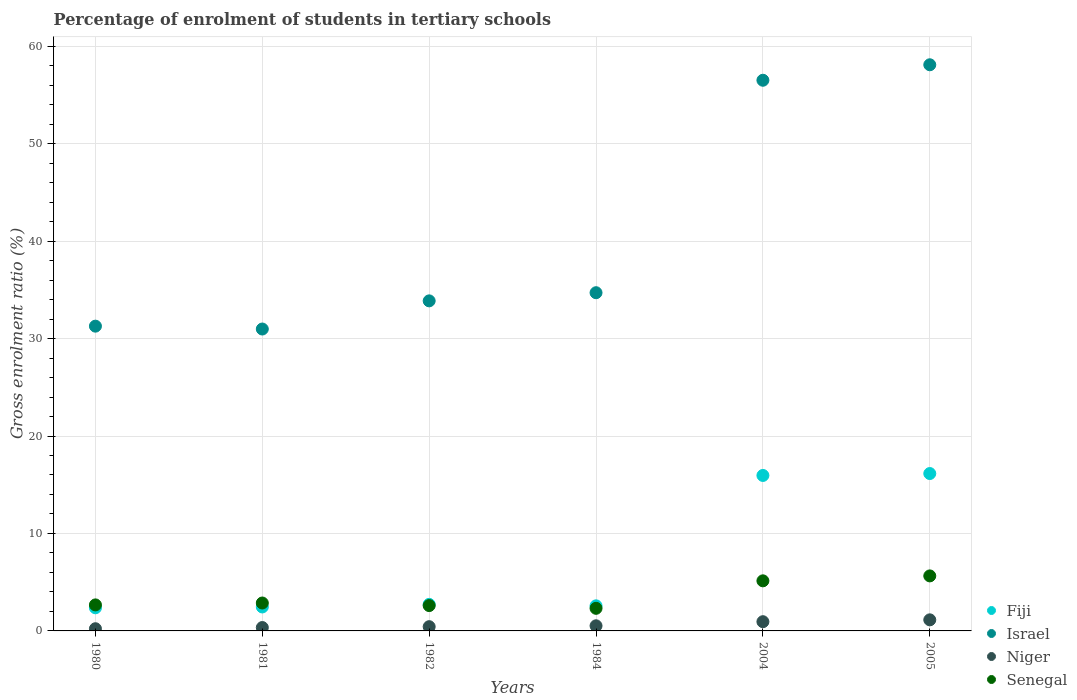What is the percentage of students enrolled in tertiary schools in Israel in 1982?
Provide a short and direct response. 33.87. Across all years, what is the maximum percentage of students enrolled in tertiary schools in Niger?
Your answer should be very brief. 1.14. Across all years, what is the minimum percentage of students enrolled in tertiary schools in Niger?
Give a very brief answer. 0.23. In which year was the percentage of students enrolled in tertiary schools in Fiji minimum?
Provide a short and direct response. 1980. What is the total percentage of students enrolled in tertiary schools in Niger in the graph?
Make the answer very short. 3.62. What is the difference between the percentage of students enrolled in tertiary schools in Niger in 1980 and that in 1984?
Give a very brief answer. -0.3. What is the difference between the percentage of students enrolled in tertiary schools in Senegal in 1984 and the percentage of students enrolled in tertiary schools in Israel in 1981?
Make the answer very short. -28.66. What is the average percentage of students enrolled in tertiary schools in Niger per year?
Keep it short and to the point. 0.6. In the year 1984, what is the difference between the percentage of students enrolled in tertiary schools in Niger and percentage of students enrolled in tertiary schools in Senegal?
Your answer should be very brief. -1.79. In how many years, is the percentage of students enrolled in tertiary schools in Niger greater than 20 %?
Your answer should be very brief. 0. What is the ratio of the percentage of students enrolled in tertiary schools in Niger in 1981 to that in 2005?
Keep it short and to the point. 0.31. Is the percentage of students enrolled in tertiary schools in Senegal in 1982 less than that in 2005?
Ensure brevity in your answer.  Yes. Is the difference between the percentage of students enrolled in tertiary schools in Niger in 1981 and 1984 greater than the difference between the percentage of students enrolled in tertiary schools in Senegal in 1981 and 1984?
Keep it short and to the point. No. What is the difference between the highest and the second highest percentage of students enrolled in tertiary schools in Niger?
Ensure brevity in your answer.  0.19. What is the difference between the highest and the lowest percentage of students enrolled in tertiary schools in Israel?
Your answer should be compact. 27.11. Is the sum of the percentage of students enrolled in tertiary schools in Senegal in 1984 and 2004 greater than the maximum percentage of students enrolled in tertiary schools in Niger across all years?
Give a very brief answer. Yes. Is it the case that in every year, the sum of the percentage of students enrolled in tertiary schools in Senegal and percentage of students enrolled in tertiary schools in Niger  is greater than the sum of percentage of students enrolled in tertiary schools in Israel and percentage of students enrolled in tertiary schools in Fiji?
Provide a short and direct response. No. Is it the case that in every year, the sum of the percentage of students enrolled in tertiary schools in Senegal and percentage of students enrolled in tertiary schools in Fiji  is greater than the percentage of students enrolled in tertiary schools in Niger?
Provide a succinct answer. Yes. Does the percentage of students enrolled in tertiary schools in Fiji monotonically increase over the years?
Provide a short and direct response. No. How many dotlines are there?
Provide a succinct answer. 4. What is the difference between two consecutive major ticks on the Y-axis?
Give a very brief answer. 10. Does the graph contain any zero values?
Make the answer very short. No. How are the legend labels stacked?
Your answer should be compact. Vertical. What is the title of the graph?
Ensure brevity in your answer.  Percentage of enrolment of students in tertiary schools. What is the label or title of the X-axis?
Your response must be concise. Years. What is the Gross enrolment ratio (%) of Fiji in 1980?
Keep it short and to the point. 2.37. What is the Gross enrolment ratio (%) of Israel in 1980?
Give a very brief answer. 31.27. What is the Gross enrolment ratio (%) in Niger in 1980?
Offer a very short reply. 0.23. What is the Gross enrolment ratio (%) in Senegal in 1980?
Provide a short and direct response. 2.67. What is the Gross enrolment ratio (%) in Fiji in 1981?
Offer a very short reply. 2.46. What is the Gross enrolment ratio (%) of Israel in 1981?
Your answer should be very brief. 30.98. What is the Gross enrolment ratio (%) in Niger in 1981?
Offer a terse response. 0.35. What is the Gross enrolment ratio (%) of Senegal in 1981?
Give a very brief answer. 2.86. What is the Gross enrolment ratio (%) of Fiji in 1982?
Provide a short and direct response. 2.72. What is the Gross enrolment ratio (%) of Israel in 1982?
Keep it short and to the point. 33.87. What is the Gross enrolment ratio (%) of Niger in 1982?
Offer a very short reply. 0.44. What is the Gross enrolment ratio (%) in Senegal in 1982?
Keep it short and to the point. 2.6. What is the Gross enrolment ratio (%) in Fiji in 1984?
Offer a terse response. 2.57. What is the Gross enrolment ratio (%) in Israel in 1984?
Your answer should be very brief. 34.7. What is the Gross enrolment ratio (%) of Niger in 1984?
Offer a terse response. 0.53. What is the Gross enrolment ratio (%) in Senegal in 1984?
Ensure brevity in your answer.  2.32. What is the Gross enrolment ratio (%) in Fiji in 2004?
Provide a succinct answer. 15.95. What is the Gross enrolment ratio (%) of Israel in 2004?
Keep it short and to the point. 56.5. What is the Gross enrolment ratio (%) in Niger in 2004?
Provide a short and direct response. 0.95. What is the Gross enrolment ratio (%) in Senegal in 2004?
Offer a very short reply. 5.14. What is the Gross enrolment ratio (%) of Fiji in 2005?
Your response must be concise. 16.15. What is the Gross enrolment ratio (%) in Israel in 2005?
Ensure brevity in your answer.  58.09. What is the Gross enrolment ratio (%) of Niger in 2005?
Offer a very short reply. 1.14. What is the Gross enrolment ratio (%) in Senegal in 2005?
Your answer should be very brief. 5.64. Across all years, what is the maximum Gross enrolment ratio (%) of Fiji?
Make the answer very short. 16.15. Across all years, what is the maximum Gross enrolment ratio (%) in Israel?
Provide a succinct answer. 58.09. Across all years, what is the maximum Gross enrolment ratio (%) of Niger?
Ensure brevity in your answer.  1.14. Across all years, what is the maximum Gross enrolment ratio (%) of Senegal?
Provide a succinct answer. 5.64. Across all years, what is the minimum Gross enrolment ratio (%) of Fiji?
Provide a succinct answer. 2.37. Across all years, what is the minimum Gross enrolment ratio (%) in Israel?
Your response must be concise. 30.98. Across all years, what is the minimum Gross enrolment ratio (%) of Niger?
Your answer should be compact. 0.23. Across all years, what is the minimum Gross enrolment ratio (%) of Senegal?
Your response must be concise. 2.32. What is the total Gross enrolment ratio (%) in Fiji in the graph?
Provide a short and direct response. 42.23. What is the total Gross enrolment ratio (%) in Israel in the graph?
Ensure brevity in your answer.  245.41. What is the total Gross enrolment ratio (%) in Niger in the graph?
Give a very brief answer. 3.62. What is the total Gross enrolment ratio (%) in Senegal in the graph?
Keep it short and to the point. 21.24. What is the difference between the Gross enrolment ratio (%) of Fiji in 1980 and that in 1981?
Offer a terse response. -0.09. What is the difference between the Gross enrolment ratio (%) in Israel in 1980 and that in 1981?
Your answer should be very brief. 0.29. What is the difference between the Gross enrolment ratio (%) of Niger in 1980 and that in 1981?
Keep it short and to the point. -0.12. What is the difference between the Gross enrolment ratio (%) in Senegal in 1980 and that in 1981?
Ensure brevity in your answer.  -0.19. What is the difference between the Gross enrolment ratio (%) of Fiji in 1980 and that in 1982?
Make the answer very short. -0.35. What is the difference between the Gross enrolment ratio (%) in Israel in 1980 and that in 1982?
Give a very brief answer. -2.6. What is the difference between the Gross enrolment ratio (%) of Niger in 1980 and that in 1982?
Your answer should be compact. -0.21. What is the difference between the Gross enrolment ratio (%) in Senegal in 1980 and that in 1982?
Provide a short and direct response. 0.07. What is the difference between the Gross enrolment ratio (%) of Fiji in 1980 and that in 1984?
Your answer should be very brief. -0.2. What is the difference between the Gross enrolment ratio (%) in Israel in 1980 and that in 1984?
Offer a terse response. -3.43. What is the difference between the Gross enrolment ratio (%) in Niger in 1980 and that in 1984?
Your response must be concise. -0.3. What is the difference between the Gross enrolment ratio (%) in Senegal in 1980 and that in 1984?
Offer a very short reply. 0.35. What is the difference between the Gross enrolment ratio (%) in Fiji in 1980 and that in 2004?
Ensure brevity in your answer.  -13.58. What is the difference between the Gross enrolment ratio (%) in Israel in 1980 and that in 2004?
Keep it short and to the point. -25.23. What is the difference between the Gross enrolment ratio (%) in Niger in 1980 and that in 2004?
Offer a terse response. -0.72. What is the difference between the Gross enrolment ratio (%) of Senegal in 1980 and that in 2004?
Provide a short and direct response. -2.47. What is the difference between the Gross enrolment ratio (%) of Fiji in 1980 and that in 2005?
Your answer should be compact. -13.78. What is the difference between the Gross enrolment ratio (%) in Israel in 1980 and that in 2005?
Your answer should be compact. -26.82. What is the difference between the Gross enrolment ratio (%) in Niger in 1980 and that in 2005?
Give a very brief answer. -0.91. What is the difference between the Gross enrolment ratio (%) in Senegal in 1980 and that in 2005?
Your response must be concise. -2.97. What is the difference between the Gross enrolment ratio (%) of Fiji in 1981 and that in 1982?
Your answer should be very brief. -0.27. What is the difference between the Gross enrolment ratio (%) of Israel in 1981 and that in 1982?
Your answer should be very brief. -2.89. What is the difference between the Gross enrolment ratio (%) in Niger in 1981 and that in 1982?
Provide a succinct answer. -0.09. What is the difference between the Gross enrolment ratio (%) in Senegal in 1981 and that in 1982?
Give a very brief answer. 0.27. What is the difference between the Gross enrolment ratio (%) in Fiji in 1981 and that in 1984?
Ensure brevity in your answer.  -0.12. What is the difference between the Gross enrolment ratio (%) of Israel in 1981 and that in 1984?
Your answer should be very brief. -3.73. What is the difference between the Gross enrolment ratio (%) in Niger in 1981 and that in 1984?
Your response must be concise. -0.18. What is the difference between the Gross enrolment ratio (%) of Senegal in 1981 and that in 1984?
Provide a short and direct response. 0.55. What is the difference between the Gross enrolment ratio (%) in Fiji in 1981 and that in 2004?
Provide a short and direct response. -13.49. What is the difference between the Gross enrolment ratio (%) in Israel in 1981 and that in 2004?
Offer a terse response. -25.53. What is the difference between the Gross enrolment ratio (%) of Niger in 1981 and that in 2004?
Make the answer very short. -0.6. What is the difference between the Gross enrolment ratio (%) in Senegal in 1981 and that in 2004?
Your answer should be very brief. -2.27. What is the difference between the Gross enrolment ratio (%) of Fiji in 1981 and that in 2005?
Provide a short and direct response. -13.69. What is the difference between the Gross enrolment ratio (%) in Israel in 1981 and that in 2005?
Offer a very short reply. -27.11. What is the difference between the Gross enrolment ratio (%) of Niger in 1981 and that in 2005?
Provide a short and direct response. -0.79. What is the difference between the Gross enrolment ratio (%) in Senegal in 1981 and that in 2005?
Your answer should be compact. -2.78. What is the difference between the Gross enrolment ratio (%) of Fiji in 1982 and that in 1984?
Your answer should be compact. 0.15. What is the difference between the Gross enrolment ratio (%) in Israel in 1982 and that in 1984?
Provide a short and direct response. -0.84. What is the difference between the Gross enrolment ratio (%) in Niger in 1982 and that in 1984?
Give a very brief answer. -0.09. What is the difference between the Gross enrolment ratio (%) of Senegal in 1982 and that in 1984?
Provide a short and direct response. 0.28. What is the difference between the Gross enrolment ratio (%) of Fiji in 1982 and that in 2004?
Provide a succinct answer. -13.23. What is the difference between the Gross enrolment ratio (%) of Israel in 1982 and that in 2004?
Provide a short and direct response. -22.64. What is the difference between the Gross enrolment ratio (%) in Niger in 1982 and that in 2004?
Offer a terse response. -0.51. What is the difference between the Gross enrolment ratio (%) in Senegal in 1982 and that in 2004?
Keep it short and to the point. -2.54. What is the difference between the Gross enrolment ratio (%) in Fiji in 1982 and that in 2005?
Offer a terse response. -13.42. What is the difference between the Gross enrolment ratio (%) of Israel in 1982 and that in 2005?
Offer a terse response. -24.22. What is the difference between the Gross enrolment ratio (%) of Niger in 1982 and that in 2005?
Provide a short and direct response. -0.7. What is the difference between the Gross enrolment ratio (%) of Senegal in 1982 and that in 2005?
Provide a short and direct response. -3.05. What is the difference between the Gross enrolment ratio (%) of Fiji in 1984 and that in 2004?
Provide a succinct answer. -13.38. What is the difference between the Gross enrolment ratio (%) in Israel in 1984 and that in 2004?
Offer a very short reply. -21.8. What is the difference between the Gross enrolment ratio (%) of Niger in 1984 and that in 2004?
Make the answer very short. -0.42. What is the difference between the Gross enrolment ratio (%) of Senegal in 1984 and that in 2004?
Your response must be concise. -2.82. What is the difference between the Gross enrolment ratio (%) of Fiji in 1984 and that in 2005?
Provide a short and direct response. -13.57. What is the difference between the Gross enrolment ratio (%) in Israel in 1984 and that in 2005?
Your answer should be compact. -23.39. What is the difference between the Gross enrolment ratio (%) in Niger in 1984 and that in 2005?
Make the answer very short. -0.61. What is the difference between the Gross enrolment ratio (%) in Senegal in 1984 and that in 2005?
Make the answer very short. -3.33. What is the difference between the Gross enrolment ratio (%) in Fiji in 2004 and that in 2005?
Offer a terse response. -0.2. What is the difference between the Gross enrolment ratio (%) of Israel in 2004 and that in 2005?
Provide a succinct answer. -1.59. What is the difference between the Gross enrolment ratio (%) of Niger in 2004 and that in 2005?
Offer a terse response. -0.19. What is the difference between the Gross enrolment ratio (%) of Senegal in 2004 and that in 2005?
Provide a short and direct response. -0.51. What is the difference between the Gross enrolment ratio (%) in Fiji in 1980 and the Gross enrolment ratio (%) in Israel in 1981?
Your answer should be compact. -28.6. What is the difference between the Gross enrolment ratio (%) in Fiji in 1980 and the Gross enrolment ratio (%) in Niger in 1981?
Provide a succinct answer. 2.03. What is the difference between the Gross enrolment ratio (%) of Fiji in 1980 and the Gross enrolment ratio (%) of Senegal in 1981?
Your answer should be very brief. -0.49. What is the difference between the Gross enrolment ratio (%) of Israel in 1980 and the Gross enrolment ratio (%) of Niger in 1981?
Provide a short and direct response. 30.92. What is the difference between the Gross enrolment ratio (%) in Israel in 1980 and the Gross enrolment ratio (%) in Senegal in 1981?
Keep it short and to the point. 28.41. What is the difference between the Gross enrolment ratio (%) in Niger in 1980 and the Gross enrolment ratio (%) in Senegal in 1981?
Provide a succinct answer. -2.64. What is the difference between the Gross enrolment ratio (%) of Fiji in 1980 and the Gross enrolment ratio (%) of Israel in 1982?
Make the answer very short. -31.49. What is the difference between the Gross enrolment ratio (%) of Fiji in 1980 and the Gross enrolment ratio (%) of Niger in 1982?
Your response must be concise. 1.94. What is the difference between the Gross enrolment ratio (%) in Fiji in 1980 and the Gross enrolment ratio (%) in Senegal in 1982?
Offer a terse response. -0.23. What is the difference between the Gross enrolment ratio (%) of Israel in 1980 and the Gross enrolment ratio (%) of Niger in 1982?
Your answer should be compact. 30.84. What is the difference between the Gross enrolment ratio (%) in Israel in 1980 and the Gross enrolment ratio (%) in Senegal in 1982?
Offer a terse response. 28.67. What is the difference between the Gross enrolment ratio (%) of Niger in 1980 and the Gross enrolment ratio (%) of Senegal in 1982?
Offer a terse response. -2.37. What is the difference between the Gross enrolment ratio (%) of Fiji in 1980 and the Gross enrolment ratio (%) of Israel in 1984?
Offer a very short reply. -32.33. What is the difference between the Gross enrolment ratio (%) in Fiji in 1980 and the Gross enrolment ratio (%) in Niger in 1984?
Your answer should be compact. 1.85. What is the difference between the Gross enrolment ratio (%) of Fiji in 1980 and the Gross enrolment ratio (%) of Senegal in 1984?
Give a very brief answer. 0.05. What is the difference between the Gross enrolment ratio (%) of Israel in 1980 and the Gross enrolment ratio (%) of Niger in 1984?
Keep it short and to the point. 30.74. What is the difference between the Gross enrolment ratio (%) in Israel in 1980 and the Gross enrolment ratio (%) in Senegal in 1984?
Make the answer very short. 28.95. What is the difference between the Gross enrolment ratio (%) of Niger in 1980 and the Gross enrolment ratio (%) of Senegal in 1984?
Keep it short and to the point. -2.09. What is the difference between the Gross enrolment ratio (%) of Fiji in 1980 and the Gross enrolment ratio (%) of Israel in 2004?
Make the answer very short. -54.13. What is the difference between the Gross enrolment ratio (%) in Fiji in 1980 and the Gross enrolment ratio (%) in Niger in 2004?
Give a very brief answer. 1.43. What is the difference between the Gross enrolment ratio (%) in Fiji in 1980 and the Gross enrolment ratio (%) in Senegal in 2004?
Make the answer very short. -2.77. What is the difference between the Gross enrolment ratio (%) of Israel in 1980 and the Gross enrolment ratio (%) of Niger in 2004?
Keep it short and to the point. 30.32. What is the difference between the Gross enrolment ratio (%) of Israel in 1980 and the Gross enrolment ratio (%) of Senegal in 2004?
Offer a very short reply. 26.13. What is the difference between the Gross enrolment ratio (%) in Niger in 1980 and the Gross enrolment ratio (%) in Senegal in 2004?
Keep it short and to the point. -4.91. What is the difference between the Gross enrolment ratio (%) of Fiji in 1980 and the Gross enrolment ratio (%) of Israel in 2005?
Your answer should be compact. -55.72. What is the difference between the Gross enrolment ratio (%) of Fiji in 1980 and the Gross enrolment ratio (%) of Niger in 2005?
Provide a short and direct response. 1.24. What is the difference between the Gross enrolment ratio (%) of Fiji in 1980 and the Gross enrolment ratio (%) of Senegal in 2005?
Your answer should be compact. -3.27. What is the difference between the Gross enrolment ratio (%) of Israel in 1980 and the Gross enrolment ratio (%) of Niger in 2005?
Offer a very short reply. 30.13. What is the difference between the Gross enrolment ratio (%) in Israel in 1980 and the Gross enrolment ratio (%) in Senegal in 2005?
Keep it short and to the point. 25.63. What is the difference between the Gross enrolment ratio (%) in Niger in 1980 and the Gross enrolment ratio (%) in Senegal in 2005?
Offer a terse response. -5.42. What is the difference between the Gross enrolment ratio (%) of Fiji in 1981 and the Gross enrolment ratio (%) of Israel in 1982?
Offer a very short reply. -31.41. What is the difference between the Gross enrolment ratio (%) of Fiji in 1981 and the Gross enrolment ratio (%) of Niger in 1982?
Your answer should be very brief. 2.02. What is the difference between the Gross enrolment ratio (%) in Fiji in 1981 and the Gross enrolment ratio (%) in Senegal in 1982?
Your response must be concise. -0.14. What is the difference between the Gross enrolment ratio (%) of Israel in 1981 and the Gross enrolment ratio (%) of Niger in 1982?
Ensure brevity in your answer.  30.54. What is the difference between the Gross enrolment ratio (%) of Israel in 1981 and the Gross enrolment ratio (%) of Senegal in 1982?
Provide a succinct answer. 28.38. What is the difference between the Gross enrolment ratio (%) of Niger in 1981 and the Gross enrolment ratio (%) of Senegal in 1982?
Make the answer very short. -2.25. What is the difference between the Gross enrolment ratio (%) of Fiji in 1981 and the Gross enrolment ratio (%) of Israel in 1984?
Your response must be concise. -32.24. What is the difference between the Gross enrolment ratio (%) of Fiji in 1981 and the Gross enrolment ratio (%) of Niger in 1984?
Your response must be concise. 1.93. What is the difference between the Gross enrolment ratio (%) in Fiji in 1981 and the Gross enrolment ratio (%) in Senegal in 1984?
Provide a succinct answer. 0.14. What is the difference between the Gross enrolment ratio (%) in Israel in 1981 and the Gross enrolment ratio (%) in Niger in 1984?
Give a very brief answer. 30.45. What is the difference between the Gross enrolment ratio (%) of Israel in 1981 and the Gross enrolment ratio (%) of Senegal in 1984?
Make the answer very short. 28.66. What is the difference between the Gross enrolment ratio (%) in Niger in 1981 and the Gross enrolment ratio (%) in Senegal in 1984?
Your answer should be very brief. -1.97. What is the difference between the Gross enrolment ratio (%) in Fiji in 1981 and the Gross enrolment ratio (%) in Israel in 2004?
Provide a succinct answer. -54.04. What is the difference between the Gross enrolment ratio (%) in Fiji in 1981 and the Gross enrolment ratio (%) in Niger in 2004?
Ensure brevity in your answer.  1.51. What is the difference between the Gross enrolment ratio (%) in Fiji in 1981 and the Gross enrolment ratio (%) in Senegal in 2004?
Provide a short and direct response. -2.68. What is the difference between the Gross enrolment ratio (%) of Israel in 1981 and the Gross enrolment ratio (%) of Niger in 2004?
Provide a succinct answer. 30.03. What is the difference between the Gross enrolment ratio (%) of Israel in 1981 and the Gross enrolment ratio (%) of Senegal in 2004?
Provide a short and direct response. 25.84. What is the difference between the Gross enrolment ratio (%) of Niger in 1981 and the Gross enrolment ratio (%) of Senegal in 2004?
Ensure brevity in your answer.  -4.79. What is the difference between the Gross enrolment ratio (%) in Fiji in 1981 and the Gross enrolment ratio (%) in Israel in 2005?
Ensure brevity in your answer.  -55.63. What is the difference between the Gross enrolment ratio (%) in Fiji in 1981 and the Gross enrolment ratio (%) in Niger in 2005?
Your answer should be compact. 1.32. What is the difference between the Gross enrolment ratio (%) in Fiji in 1981 and the Gross enrolment ratio (%) in Senegal in 2005?
Offer a very short reply. -3.19. What is the difference between the Gross enrolment ratio (%) in Israel in 1981 and the Gross enrolment ratio (%) in Niger in 2005?
Keep it short and to the point. 29.84. What is the difference between the Gross enrolment ratio (%) of Israel in 1981 and the Gross enrolment ratio (%) of Senegal in 2005?
Make the answer very short. 25.33. What is the difference between the Gross enrolment ratio (%) in Niger in 1981 and the Gross enrolment ratio (%) in Senegal in 2005?
Provide a succinct answer. -5.3. What is the difference between the Gross enrolment ratio (%) of Fiji in 1982 and the Gross enrolment ratio (%) of Israel in 1984?
Your response must be concise. -31.98. What is the difference between the Gross enrolment ratio (%) of Fiji in 1982 and the Gross enrolment ratio (%) of Niger in 1984?
Offer a terse response. 2.2. What is the difference between the Gross enrolment ratio (%) of Fiji in 1982 and the Gross enrolment ratio (%) of Senegal in 1984?
Your answer should be compact. 0.41. What is the difference between the Gross enrolment ratio (%) of Israel in 1982 and the Gross enrolment ratio (%) of Niger in 1984?
Your response must be concise. 33.34. What is the difference between the Gross enrolment ratio (%) of Israel in 1982 and the Gross enrolment ratio (%) of Senegal in 1984?
Your answer should be very brief. 31.55. What is the difference between the Gross enrolment ratio (%) of Niger in 1982 and the Gross enrolment ratio (%) of Senegal in 1984?
Offer a very short reply. -1.88. What is the difference between the Gross enrolment ratio (%) of Fiji in 1982 and the Gross enrolment ratio (%) of Israel in 2004?
Make the answer very short. -53.78. What is the difference between the Gross enrolment ratio (%) in Fiji in 1982 and the Gross enrolment ratio (%) in Niger in 2004?
Your response must be concise. 1.78. What is the difference between the Gross enrolment ratio (%) in Fiji in 1982 and the Gross enrolment ratio (%) in Senegal in 2004?
Offer a very short reply. -2.41. What is the difference between the Gross enrolment ratio (%) of Israel in 1982 and the Gross enrolment ratio (%) of Niger in 2004?
Give a very brief answer. 32.92. What is the difference between the Gross enrolment ratio (%) of Israel in 1982 and the Gross enrolment ratio (%) of Senegal in 2004?
Give a very brief answer. 28.73. What is the difference between the Gross enrolment ratio (%) of Niger in 1982 and the Gross enrolment ratio (%) of Senegal in 2004?
Offer a very short reply. -4.7. What is the difference between the Gross enrolment ratio (%) of Fiji in 1982 and the Gross enrolment ratio (%) of Israel in 2005?
Provide a succinct answer. -55.37. What is the difference between the Gross enrolment ratio (%) in Fiji in 1982 and the Gross enrolment ratio (%) in Niger in 2005?
Offer a terse response. 1.59. What is the difference between the Gross enrolment ratio (%) in Fiji in 1982 and the Gross enrolment ratio (%) in Senegal in 2005?
Offer a very short reply. -2.92. What is the difference between the Gross enrolment ratio (%) of Israel in 1982 and the Gross enrolment ratio (%) of Niger in 2005?
Offer a very short reply. 32.73. What is the difference between the Gross enrolment ratio (%) of Israel in 1982 and the Gross enrolment ratio (%) of Senegal in 2005?
Your answer should be compact. 28.22. What is the difference between the Gross enrolment ratio (%) in Niger in 1982 and the Gross enrolment ratio (%) in Senegal in 2005?
Ensure brevity in your answer.  -5.21. What is the difference between the Gross enrolment ratio (%) of Fiji in 1984 and the Gross enrolment ratio (%) of Israel in 2004?
Your answer should be compact. -53.93. What is the difference between the Gross enrolment ratio (%) in Fiji in 1984 and the Gross enrolment ratio (%) in Niger in 2004?
Keep it short and to the point. 1.63. What is the difference between the Gross enrolment ratio (%) of Fiji in 1984 and the Gross enrolment ratio (%) of Senegal in 2004?
Offer a terse response. -2.57. What is the difference between the Gross enrolment ratio (%) of Israel in 1984 and the Gross enrolment ratio (%) of Niger in 2004?
Make the answer very short. 33.76. What is the difference between the Gross enrolment ratio (%) in Israel in 1984 and the Gross enrolment ratio (%) in Senegal in 2004?
Your answer should be compact. 29.56. What is the difference between the Gross enrolment ratio (%) in Niger in 1984 and the Gross enrolment ratio (%) in Senegal in 2004?
Your answer should be compact. -4.61. What is the difference between the Gross enrolment ratio (%) in Fiji in 1984 and the Gross enrolment ratio (%) in Israel in 2005?
Offer a terse response. -55.52. What is the difference between the Gross enrolment ratio (%) in Fiji in 1984 and the Gross enrolment ratio (%) in Niger in 2005?
Provide a short and direct response. 1.44. What is the difference between the Gross enrolment ratio (%) of Fiji in 1984 and the Gross enrolment ratio (%) of Senegal in 2005?
Offer a very short reply. -3.07. What is the difference between the Gross enrolment ratio (%) of Israel in 1984 and the Gross enrolment ratio (%) of Niger in 2005?
Keep it short and to the point. 33.57. What is the difference between the Gross enrolment ratio (%) of Israel in 1984 and the Gross enrolment ratio (%) of Senegal in 2005?
Your response must be concise. 29.06. What is the difference between the Gross enrolment ratio (%) in Niger in 1984 and the Gross enrolment ratio (%) in Senegal in 2005?
Offer a terse response. -5.12. What is the difference between the Gross enrolment ratio (%) in Fiji in 2004 and the Gross enrolment ratio (%) in Israel in 2005?
Keep it short and to the point. -42.14. What is the difference between the Gross enrolment ratio (%) in Fiji in 2004 and the Gross enrolment ratio (%) in Niger in 2005?
Ensure brevity in your answer.  14.81. What is the difference between the Gross enrolment ratio (%) of Fiji in 2004 and the Gross enrolment ratio (%) of Senegal in 2005?
Provide a succinct answer. 10.31. What is the difference between the Gross enrolment ratio (%) of Israel in 2004 and the Gross enrolment ratio (%) of Niger in 2005?
Your response must be concise. 55.37. What is the difference between the Gross enrolment ratio (%) in Israel in 2004 and the Gross enrolment ratio (%) in Senegal in 2005?
Provide a succinct answer. 50.86. What is the difference between the Gross enrolment ratio (%) of Niger in 2004 and the Gross enrolment ratio (%) of Senegal in 2005?
Ensure brevity in your answer.  -4.7. What is the average Gross enrolment ratio (%) of Fiji per year?
Offer a very short reply. 7.04. What is the average Gross enrolment ratio (%) of Israel per year?
Provide a succinct answer. 40.9. What is the average Gross enrolment ratio (%) of Niger per year?
Keep it short and to the point. 0.6. What is the average Gross enrolment ratio (%) in Senegal per year?
Give a very brief answer. 3.54. In the year 1980, what is the difference between the Gross enrolment ratio (%) in Fiji and Gross enrolment ratio (%) in Israel?
Offer a terse response. -28.9. In the year 1980, what is the difference between the Gross enrolment ratio (%) of Fiji and Gross enrolment ratio (%) of Niger?
Your answer should be very brief. 2.15. In the year 1980, what is the difference between the Gross enrolment ratio (%) in Fiji and Gross enrolment ratio (%) in Senegal?
Keep it short and to the point. -0.3. In the year 1980, what is the difference between the Gross enrolment ratio (%) of Israel and Gross enrolment ratio (%) of Niger?
Offer a very short reply. 31.05. In the year 1980, what is the difference between the Gross enrolment ratio (%) in Israel and Gross enrolment ratio (%) in Senegal?
Keep it short and to the point. 28.6. In the year 1980, what is the difference between the Gross enrolment ratio (%) in Niger and Gross enrolment ratio (%) in Senegal?
Offer a terse response. -2.44. In the year 1981, what is the difference between the Gross enrolment ratio (%) in Fiji and Gross enrolment ratio (%) in Israel?
Ensure brevity in your answer.  -28.52. In the year 1981, what is the difference between the Gross enrolment ratio (%) of Fiji and Gross enrolment ratio (%) of Niger?
Offer a terse response. 2.11. In the year 1981, what is the difference between the Gross enrolment ratio (%) in Fiji and Gross enrolment ratio (%) in Senegal?
Make the answer very short. -0.41. In the year 1981, what is the difference between the Gross enrolment ratio (%) of Israel and Gross enrolment ratio (%) of Niger?
Make the answer very short. 30.63. In the year 1981, what is the difference between the Gross enrolment ratio (%) of Israel and Gross enrolment ratio (%) of Senegal?
Your response must be concise. 28.11. In the year 1981, what is the difference between the Gross enrolment ratio (%) of Niger and Gross enrolment ratio (%) of Senegal?
Give a very brief answer. -2.52. In the year 1982, what is the difference between the Gross enrolment ratio (%) in Fiji and Gross enrolment ratio (%) in Israel?
Offer a terse response. -31.14. In the year 1982, what is the difference between the Gross enrolment ratio (%) in Fiji and Gross enrolment ratio (%) in Niger?
Your response must be concise. 2.29. In the year 1982, what is the difference between the Gross enrolment ratio (%) in Fiji and Gross enrolment ratio (%) in Senegal?
Keep it short and to the point. 0.13. In the year 1982, what is the difference between the Gross enrolment ratio (%) of Israel and Gross enrolment ratio (%) of Niger?
Give a very brief answer. 33.43. In the year 1982, what is the difference between the Gross enrolment ratio (%) of Israel and Gross enrolment ratio (%) of Senegal?
Provide a succinct answer. 31.27. In the year 1982, what is the difference between the Gross enrolment ratio (%) of Niger and Gross enrolment ratio (%) of Senegal?
Your response must be concise. -2.16. In the year 1984, what is the difference between the Gross enrolment ratio (%) of Fiji and Gross enrolment ratio (%) of Israel?
Your response must be concise. -32.13. In the year 1984, what is the difference between the Gross enrolment ratio (%) in Fiji and Gross enrolment ratio (%) in Niger?
Your answer should be very brief. 2.05. In the year 1984, what is the difference between the Gross enrolment ratio (%) of Fiji and Gross enrolment ratio (%) of Senegal?
Your response must be concise. 0.26. In the year 1984, what is the difference between the Gross enrolment ratio (%) of Israel and Gross enrolment ratio (%) of Niger?
Provide a short and direct response. 34.18. In the year 1984, what is the difference between the Gross enrolment ratio (%) of Israel and Gross enrolment ratio (%) of Senegal?
Offer a very short reply. 32.38. In the year 1984, what is the difference between the Gross enrolment ratio (%) in Niger and Gross enrolment ratio (%) in Senegal?
Your answer should be compact. -1.79. In the year 2004, what is the difference between the Gross enrolment ratio (%) in Fiji and Gross enrolment ratio (%) in Israel?
Ensure brevity in your answer.  -40.55. In the year 2004, what is the difference between the Gross enrolment ratio (%) of Fiji and Gross enrolment ratio (%) of Niger?
Your answer should be compact. 15.01. In the year 2004, what is the difference between the Gross enrolment ratio (%) in Fiji and Gross enrolment ratio (%) in Senegal?
Provide a succinct answer. 10.81. In the year 2004, what is the difference between the Gross enrolment ratio (%) in Israel and Gross enrolment ratio (%) in Niger?
Provide a short and direct response. 55.56. In the year 2004, what is the difference between the Gross enrolment ratio (%) of Israel and Gross enrolment ratio (%) of Senegal?
Your answer should be compact. 51.36. In the year 2004, what is the difference between the Gross enrolment ratio (%) of Niger and Gross enrolment ratio (%) of Senegal?
Ensure brevity in your answer.  -4.19. In the year 2005, what is the difference between the Gross enrolment ratio (%) of Fiji and Gross enrolment ratio (%) of Israel?
Ensure brevity in your answer.  -41.94. In the year 2005, what is the difference between the Gross enrolment ratio (%) of Fiji and Gross enrolment ratio (%) of Niger?
Your answer should be very brief. 15.01. In the year 2005, what is the difference between the Gross enrolment ratio (%) of Fiji and Gross enrolment ratio (%) of Senegal?
Your response must be concise. 10.5. In the year 2005, what is the difference between the Gross enrolment ratio (%) of Israel and Gross enrolment ratio (%) of Niger?
Offer a very short reply. 56.95. In the year 2005, what is the difference between the Gross enrolment ratio (%) in Israel and Gross enrolment ratio (%) in Senegal?
Offer a very short reply. 52.45. In the year 2005, what is the difference between the Gross enrolment ratio (%) in Niger and Gross enrolment ratio (%) in Senegal?
Offer a very short reply. -4.51. What is the ratio of the Gross enrolment ratio (%) of Fiji in 1980 to that in 1981?
Your answer should be compact. 0.97. What is the ratio of the Gross enrolment ratio (%) in Israel in 1980 to that in 1981?
Ensure brevity in your answer.  1.01. What is the ratio of the Gross enrolment ratio (%) in Niger in 1980 to that in 1981?
Offer a terse response. 0.65. What is the ratio of the Gross enrolment ratio (%) of Senegal in 1980 to that in 1981?
Your answer should be compact. 0.93. What is the ratio of the Gross enrolment ratio (%) of Fiji in 1980 to that in 1982?
Keep it short and to the point. 0.87. What is the ratio of the Gross enrolment ratio (%) of Israel in 1980 to that in 1982?
Ensure brevity in your answer.  0.92. What is the ratio of the Gross enrolment ratio (%) in Niger in 1980 to that in 1982?
Keep it short and to the point. 0.52. What is the ratio of the Gross enrolment ratio (%) of Senegal in 1980 to that in 1982?
Your answer should be compact. 1.03. What is the ratio of the Gross enrolment ratio (%) in Fiji in 1980 to that in 1984?
Offer a very short reply. 0.92. What is the ratio of the Gross enrolment ratio (%) in Israel in 1980 to that in 1984?
Your response must be concise. 0.9. What is the ratio of the Gross enrolment ratio (%) of Niger in 1980 to that in 1984?
Offer a terse response. 0.43. What is the ratio of the Gross enrolment ratio (%) of Senegal in 1980 to that in 1984?
Offer a very short reply. 1.15. What is the ratio of the Gross enrolment ratio (%) in Fiji in 1980 to that in 2004?
Provide a succinct answer. 0.15. What is the ratio of the Gross enrolment ratio (%) of Israel in 1980 to that in 2004?
Provide a succinct answer. 0.55. What is the ratio of the Gross enrolment ratio (%) of Niger in 1980 to that in 2004?
Your answer should be compact. 0.24. What is the ratio of the Gross enrolment ratio (%) in Senegal in 1980 to that in 2004?
Your answer should be compact. 0.52. What is the ratio of the Gross enrolment ratio (%) in Fiji in 1980 to that in 2005?
Keep it short and to the point. 0.15. What is the ratio of the Gross enrolment ratio (%) of Israel in 1980 to that in 2005?
Your answer should be compact. 0.54. What is the ratio of the Gross enrolment ratio (%) of Niger in 1980 to that in 2005?
Provide a short and direct response. 0.2. What is the ratio of the Gross enrolment ratio (%) of Senegal in 1980 to that in 2005?
Make the answer very short. 0.47. What is the ratio of the Gross enrolment ratio (%) in Fiji in 1981 to that in 1982?
Ensure brevity in your answer.  0.9. What is the ratio of the Gross enrolment ratio (%) in Israel in 1981 to that in 1982?
Offer a very short reply. 0.91. What is the ratio of the Gross enrolment ratio (%) in Niger in 1981 to that in 1982?
Give a very brief answer. 0.8. What is the ratio of the Gross enrolment ratio (%) of Senegal in 1981 to that in 1982?
Ensure brevity in your answer.  1.1. What is the ratio of the Gross enrolment ratio (%) in Fiji in 1981 to that in 1984?
Ensure brevity in your answer.  0.96. What is the ratio of the Gross enrolment ratio (%) of Israel in 1981 to that in 1984?
Make the answer very short. 0.89. What is the ratio of the Gross enrolment ratio (%) in Niger in 1981 to that in 1984?
Offer a terse response. 0.66. What is the ratio of the Gross enrolment ratio (%) of Senegal in 1981 to that in 1984?
Offer a very short reply. 1.24. What is the ratio of the Gross enrolment ratio (%) in Fiji in 1981 to that in 2004?
Give a very brief answer. 0.15. What is the ratio of the Gross enrolment ratio (%) in Israel in 1981 to that in 2004?
Offer a terse response. 0.55. What is the ratio of the Gross enrolment ratio (%) in Niger in 1981 to that in 2004?
Ensure brevity in your answer.  0.37. What is the ratio of the Gross enrolment ratio (%) in Senegal in 1981 to that in 2004?
Offer a terse response. 0.56. What is the ratio of the Gross enrolment ratio (%) in Fiji in 1981 to that in 2005?
Keep it short and to the point. 0.15. What is the ratio of the Gross enrolment ratio (%) in Israel in 1981 to that in 2005?
Keep it short and to the point. 0.53. What is the ratio of the Gross enrolment ratio (%) in Niger in 1981 to that in 2005?
Your response must be concise. 0.31. What is the ratio of the Gross enrolment ratio (%) of Senegal in 1981 to that in 2005?
Provide a short and direct response. 0.51. What is the ratio of the Gross enrolment ratio (%) in Fiji in 1982 to that in 1984?
Provide a succinct answer. 1.06. What is the ratio of the Gross enrolment ratio (%) of Israel in 1982 to that in 1984?
Provide a short and direct response. 0.98. What is the ratio of the Gross enrolment ratio (%) of Niger in 1982 to that in 1984?
Make the answer very short. 0.83. What is the ratio of the Gross enrolment ratio (%) in Senegal in 1982 to that in 1984?
Give a very brief answer. 1.12. What is the ratio of the Gross enrolment ratio (%) in Fiji in 1982 to that in 2004?
Provide a succinct answer. 0.17. What is the ratio of the Gross enrolment ratio (%) of Israel in 1982 to that in 2004?
Make the answer very short. 0.6. What is the ratio of the Gross enrolment ratio (%) in Niger in 1982 to that in 2004?
Your response must be concise. 0.46. What is the ratio of the Gross enrolment ratio (%) of Senegal in 1982 to that in 2004?
Your answer should be very brief. 0.51. What is the ratio of the Gross enrolment ratio (%) in Fiji in 1982 to that in 2005?
Your answer should be compact. 0.17. What is the ratio of the Gross enrolment ratio (%) in Israel in 1982 to that in 2005?
Make the answer very short. 0.58. What is the ratio of the Gross enrolment ratio (%) in Niger in 1982 to that in 2005?
Make the answer very short. 0.38. What is the ratio of the Gross enrolment ratio (%) of Senegal in 1982 to that in 2005?
Ensure brevity in your answer.  0.46. What is the ratio of the Gross enrolment ratio (%) of Fiji in 1984 to that in 2004?
Your answer should be very brief. 0.16. What is the ratio of the Gross enrolment ratio (%) in Israel in 1984 to that in 2004?
Ensure brevity in your answer.  0.61. What is the ratio of the Gross enrolment ratio (%) of Niger in 1984 to that in 2004?
Offer a terse response. 0.56. What is the ratio of the Gross enrolment ratio (%) in Senegal in 1984 to that in 2004?
Keep it short and to the point. 0.45. What is the ratio of the Gross enrolment ratio (%) in Fiji in 1984 to that in 2005?
Your answer should be very brief. 0.16. What is the ratio of the Gross enrolment ratio (%) of Israel in 1984 to that in 2005?
Your response must be concise. 0.6. What is the ratio of the Gross enrolment ratio (%) of Niger in 1984 to that in 2005?
Your answer should be very brief. 0.46. What is the ratio of the Gross enrolment ratio (%) of Senegal in 1984 to that in 2005?
Provide a succinct answer. 0.41. What is the ratio of the Gross enrolment ratio (%) of Israel in 2004 to that in 2005?
Your answer should be very brief. 0.97. What is the ratio of the Gross enrolment ratio (%) in Niger in 2004 to that in 2005?
Your answer should be compact. 0.83. What is the ratio of the Gross enrolment ratio (%) of Senegal in 2004 to that in 2005?
Offer a terse response. 0.91. What is the difference between the highest and the second highest Gross enrolment ratio (%) of Fiji?
Ensure brevity in your answer.  0.2. What is the difference between the highest and the second highest Gross enrolment ratio (%) in Israel?
Your answer should be compact. 1.59. What is the difference between the highest and the second highest Gross enrolment ratio (%) of Niger?
Keep it short and to the point. 0.19. What is the difference between the highest and the second highest Gross enrolment ratio (%) in Senegal?
Provide a succinct answer. 0.51. What is the difference between the highest and the lowest Gross enrolment ratio (%) of Fiji?
Ensure brevity in your answer.  13.78. What is the difference between the highest and the lowest Gross enrolment ratio (%) in Israel?
Your answer should be very brief. 27.11. What is the difference between the highest and the lowest Gross enrolment ratio (%) in Niger?
Ensure brevity in your answer.  0.91. What is the difference between the highest and the lowest Gross enrolment ratio (%) in Senegal?
Make the answer very short. 3.33. 